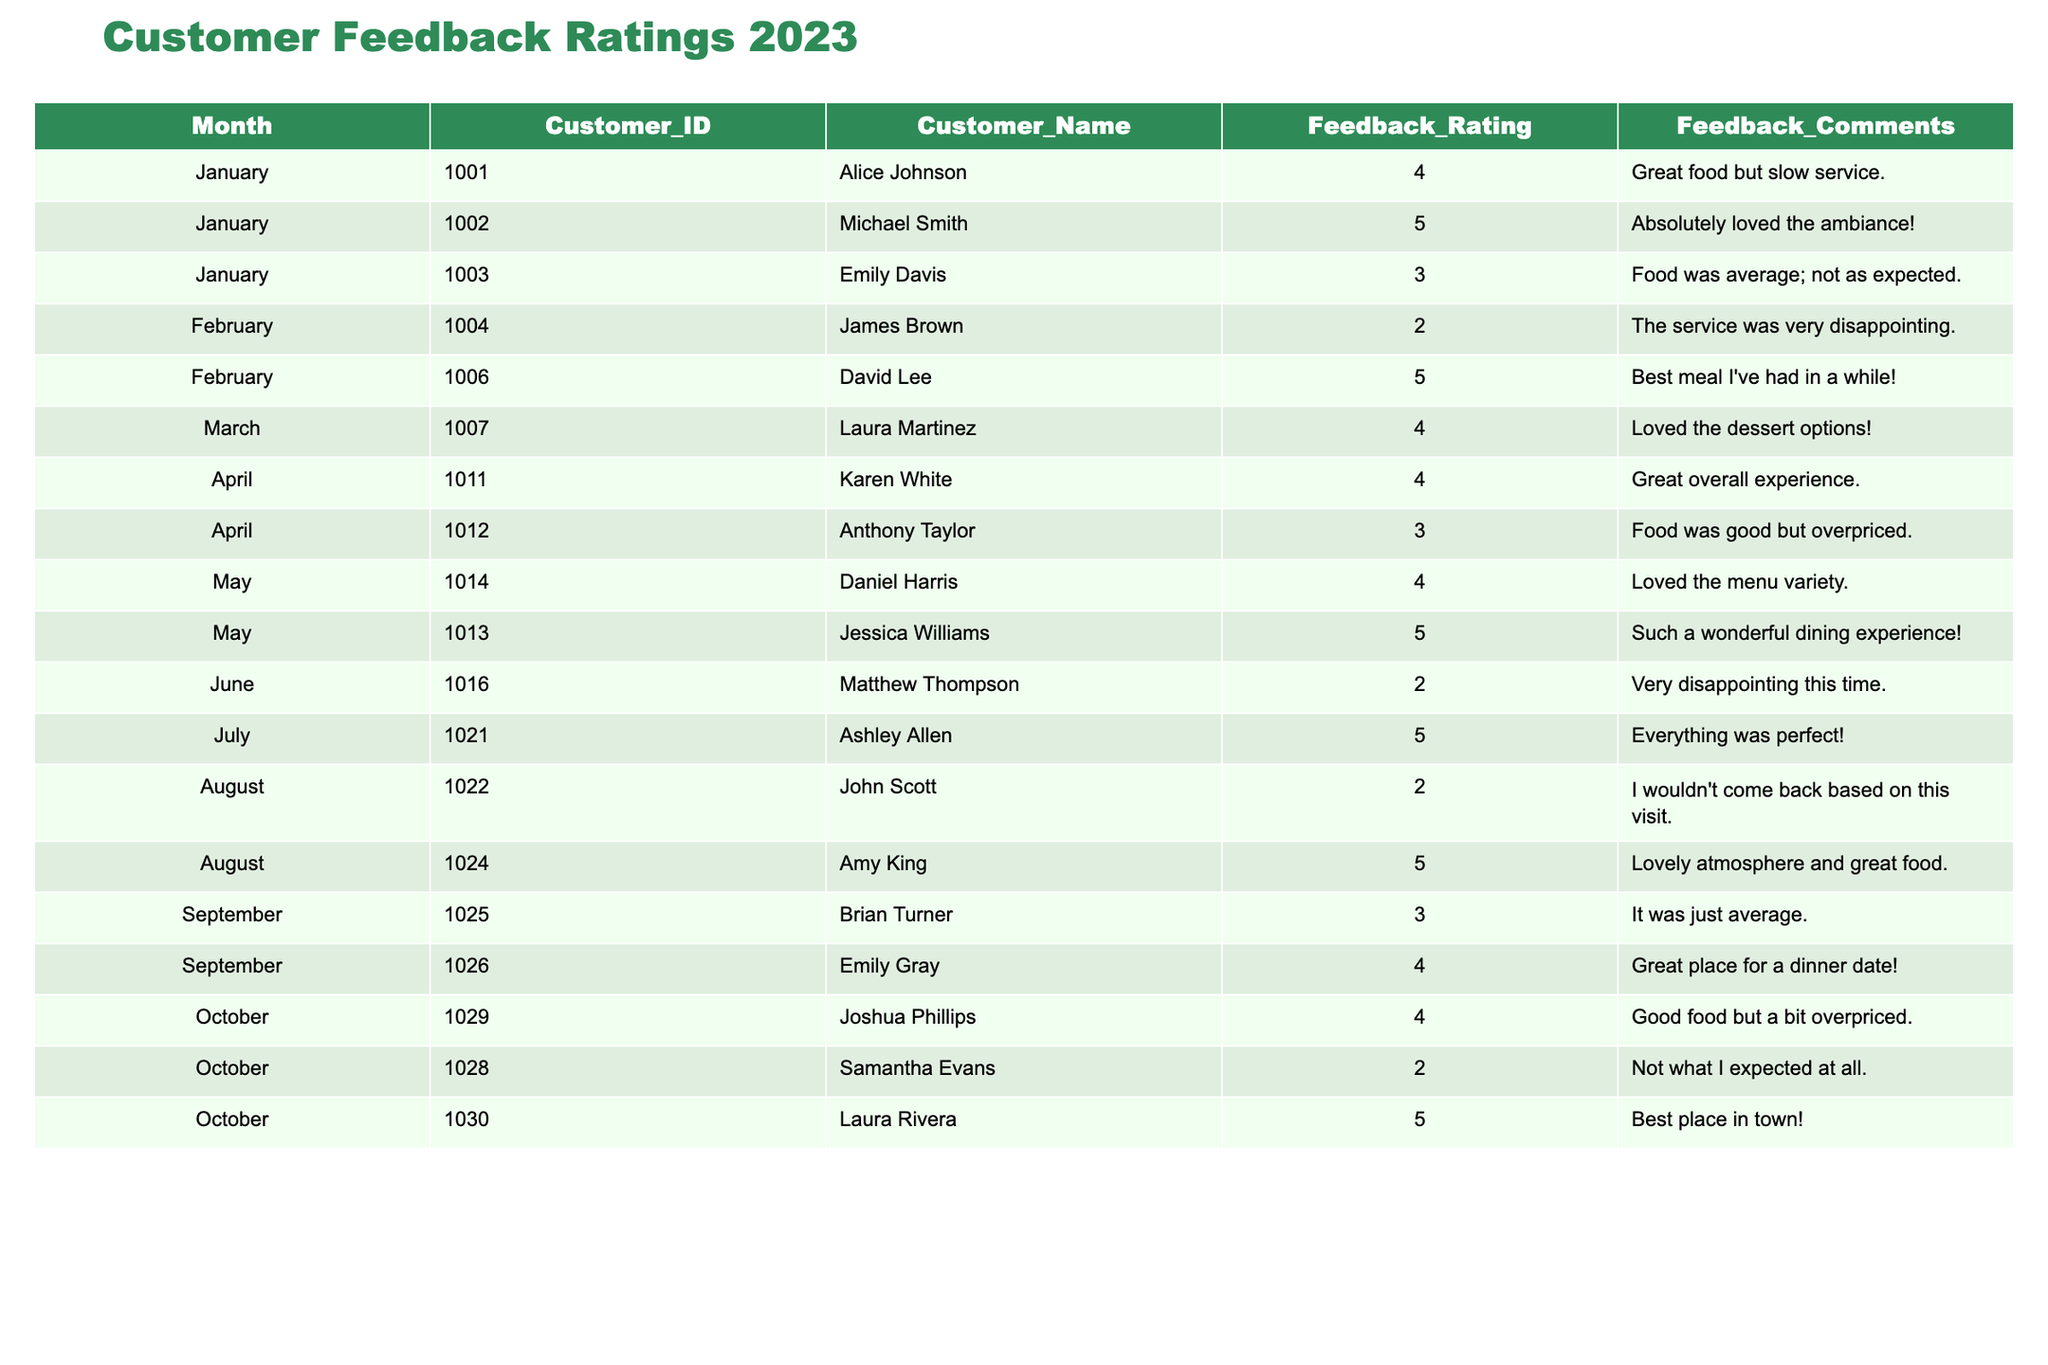What was the highest feedback rating in January? The highest feedback rating in January is 5, given by Michael Smith. I find this by looking at all feedback ratings for January and identifying the maximum value.
Answer: 5 How many customers provided feedback in March? There is 1 customer who provided feedback in March, as I can see there is only one entry for that month in the table.
Answer: 1 Which month had the lowest average feedback rating? To find the lowest average rating, I look at the feedback ratings for each month. The average for February is (2 + 5) / 2 = 3.5, March is 4, April is (4 + 3) / 2 = 3.5, and so on. The month with the lowest average is February at 3.5.
Answer: February What are the names of customers who provided a feedback rating of 5? I review the table and see that customers giving a 5 rating were Michael Smith, David Lee, Jessica Williams, Ashley Allen, Amy King, and Laura Rivera.
Answer: Michael Smith, David Lee, Jessica Williams, Ashley Allen, Amy King, Laura Rivera Did any customer give a rating of 1 or lower? No, after reviewing the ratings in the table, all feedback ratings are above 1, so no customer provided a rating of 1 or lower.
Answer: No What is the overall average feedback rating for the year so far? To calculate the overall average rating for all customers, I sum all feedback ratings (4+5+3+2+5+4+4+3+5+4+2+5+3+4+2+4+5) = 63 and divide by the total number of ratings, which is 15. So 63 / 15 = 4.2.
Answer: 4.2 Which month had more ratings above 4, February or April? February has 1 rating above 4 (5), whereas April has 2 ratings above 4 (4 and 5). Thus, April has more ratings above 4 than February.
Answer: April What is the difference between the highest and lowest ratings received in August? In August, the ratings are 2 and 5. The difference between the highest (5) and lowest (2) is 5 - 2 = 3.
Answer: 3 How many customers rated their experience as average (a score of 3)? I count the instances of a 3 rating in the table. There are 4 customers (Emily Davis, Anthony Taylor, Brian Turner, and September's rating).
Answer: 4 Is there a month where all ratings are above 3? Yes, in May, all feedback ratings are above 3 (5 and 4), as I verify all entries for that month.
Answer: Yes How many customers gave feedback ratings in total during the months of June and July? For June, there are 1 customer, and for July, 1 customer, making a total of 1 + 1 = 2 customers that provided feedback ratings in these two months.
Answer: 2 